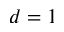<formula> <loc_0><loc_0><loc_500><loc_500>d = 1</formula> 